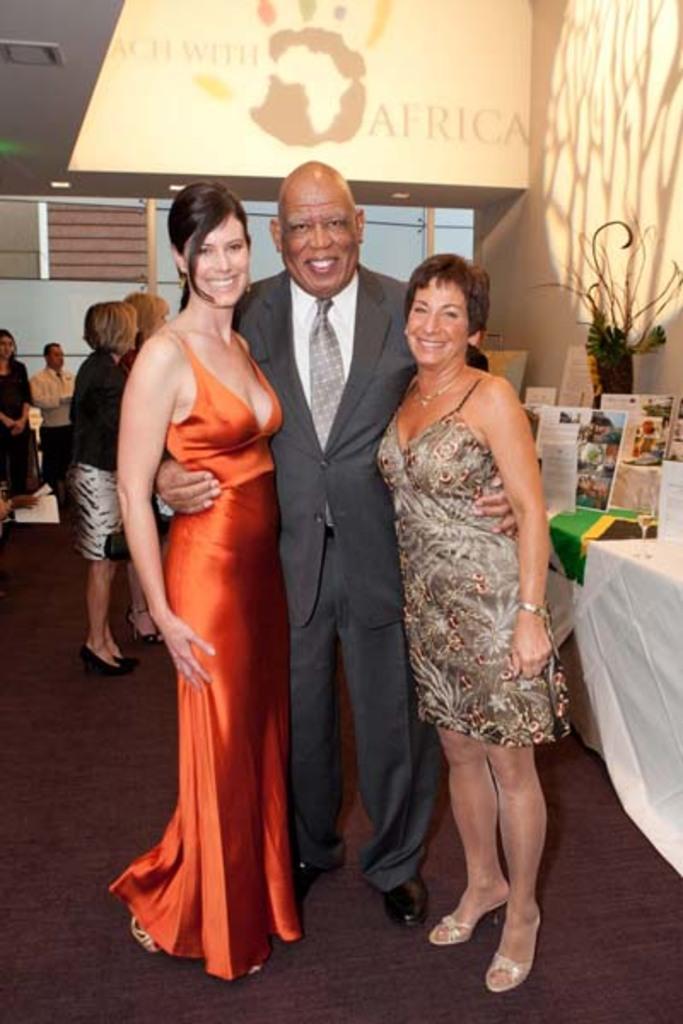Describe this image in one or two sentences. A man is standing by keeping the hands on these two girls. Here a beautiful girl is smiling, she wore an orange color dress. 